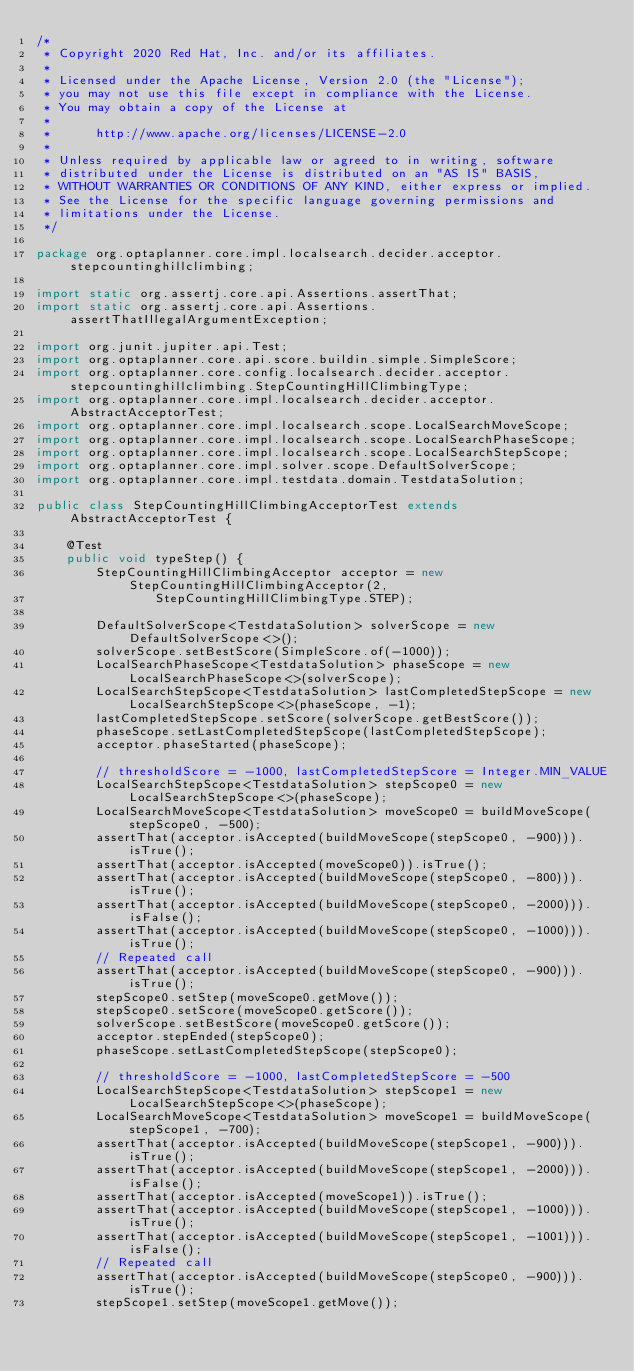<code> <loc_0><loc_0><loc_500><loc_500><_Java_>/*
 * Copyright 2020 Red Hat, Inc. and/or its affiliates.
 *
 * Licensed under the Apache License, Version 2.0 (the "License");
 * you may not use this file except in compliance with the License.
 * You may obtain a copy of the License at
 *
 *      http://www.apache.org/licenses/LICENSE-2.0
 *
 * Unless required by applicable law or agreed to in writing, software
 * distributed under the License is distributed on an "AS IS" BASIS,
 * WITHOUT WARRANTIES OR CONDITIONS OF ANY KIND, either express or implied.
 * See the License for the specific language governing permissions and
 * limitations under the License.
 */

package org.optaplanner.core.impl.localsearch.decider.acceptor.stepcountinghillclimbing;

import static org.assertj.core.api.Assertions.assertThat;
import static org.assertj.core.api.Assertions.assertThatIllegalArgumentException;

import org.junit.jupiter.api.Test;
import org.optaplanner.core.api.score.buildin.simple.SimpleScore;
import org.optaplanner.core.config.localsearch.decider.acceptor.stepcountinghillclimbing.StepCountingHillClimbingType;
import org.optaplanner.core.impl.localsearch.decider.acceptor.AbstractAcceptorTest;
import org.optaplanner.core.impl.localsearch.scope.LocalSearchMoveScope;
import org.optaplanner.core.impl.localsearch.scope.LocalSearchPhaseScope;
import org.optaplanner.core.impl.localsearch.scope.LocalSearchStepScope;
import org.optaplanner.core.impl.solver.scope.DefaultSolverScope;
import org.optaplanner.core.impl.testdata.domain.TestdataSolution;

public class StepCountingHillClimbingAcceptorTest extends AbstractAcceptorTest {

    @Test
    public void typeStep() {
        StepCountingHillClimbingAcceptor acceptor = new StepCountingHillClimbingAcceptor(2,
                StepCountingHillClimbingType.STEP);

        DefaultSolverScope<TestdataSolution> solverScope = new DefaultSolverScope<>();
        solverScope.setBestScore(SimpleScore.of(-1000));
        LocalSearchPhaseScope<TestdataSolution> phaseScope = new LocalSearchPhaseScope<>(solverScope);
        LocalSearchStepScope<TestdataSolution> lastCompletedStepScope = new LocalSearchStepScope<>(phaseScope, -1);
        lastCompletedStepScope.setScore(solverScope.getBestScore());
        phaseScope.setLastCompletedStepScope(lastCompletedStepScope);
        acceptor.phaseStarted(phaseScope);

        // thresholdScore = -1000, lastCompletedStepScore = Integer.MIN_VALUE
        LocalSearchStepScope<TestdataSolution> stepScope0 = new LocalSearchStepScope<>(phaseScope);
        LocalSearchMoveScope<TestdataSolution> moveScope0 = buildMoveScope(stepScope0, -500);
        assertThat(acceptor.isAccepted(buildMoveScope(stepScope0, -900))).isTrue();
        assertThat(acceptor.isAccepted(moveScope0)).isTrue();
        assertThat(acceptor.isAccepted(buildMoveScope(stepScope0, -800))).isTrue();
        assertThat(acceptor.isAccepted(buildMoveScope(stepScope0, -2000))).isFalse();
        assertThat(acceptor.isAccepted(buildMoveScope(stepScope0, -1000))).isTrue();
        // Repeated call
        assertThat(acceptor.isAccepted(buildMoveScope(stepScope0, -900))).isTrue();
        stepScope0.setStep(moveScope0.getMove());
        stepScope0.setScore(moveScope0.getScore());
        solverScope.setBestScore(moveScope0.getScore());
        acceptor.stepEnded(stepScope0);
        phaseScope.setLastCompletedStepScope(stepScope0);

        // thresholdScore = -1000, lastCompletedStepScore = -500
        LocalSearchStepScope<TestdataSolution> stepScope1 = new LocalSearchStepScope<>(phaseScope);
        LocalSearchMoveScope<TestdataSolution> moveScope1 = buildMoveScope(stepScope1, -700);
        assertThat(acceptor.isAccepted(buildMoveScope(stepScope1, -900))).isTrue();
        assertThat(acceptor.isAccepted(buildMoveScope(stepScope1, -2000))).isFalse();
        assertThat(acceptor.isAccepted(moveScope1)).isTrue();
        assertThat(acceptor.isAccepted(buildMoveScope(stepScope1, -1000))).isTrue();
        assertThat(acceptor.isAccepted(buildMoveScope(stepScope1, -1001))).isFalse();
        // Repeated call
        assertThat(acceptor.isAccepted(buildMoveScope(stepScope0, -900))).isTrue();
        stepScope1.setStep(moveScope1.getMove());</code> 